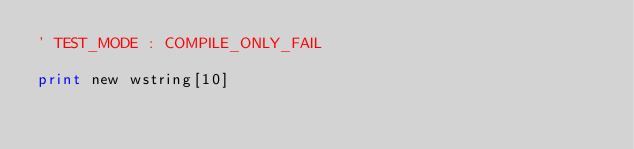Convert code to text. <code><loc_0><loc_0><loc_500><loc_500><_VisualBasic_>' TEST_MODE : COMPILE_ONLY_FAIL

print new wstring[10]
</code> 